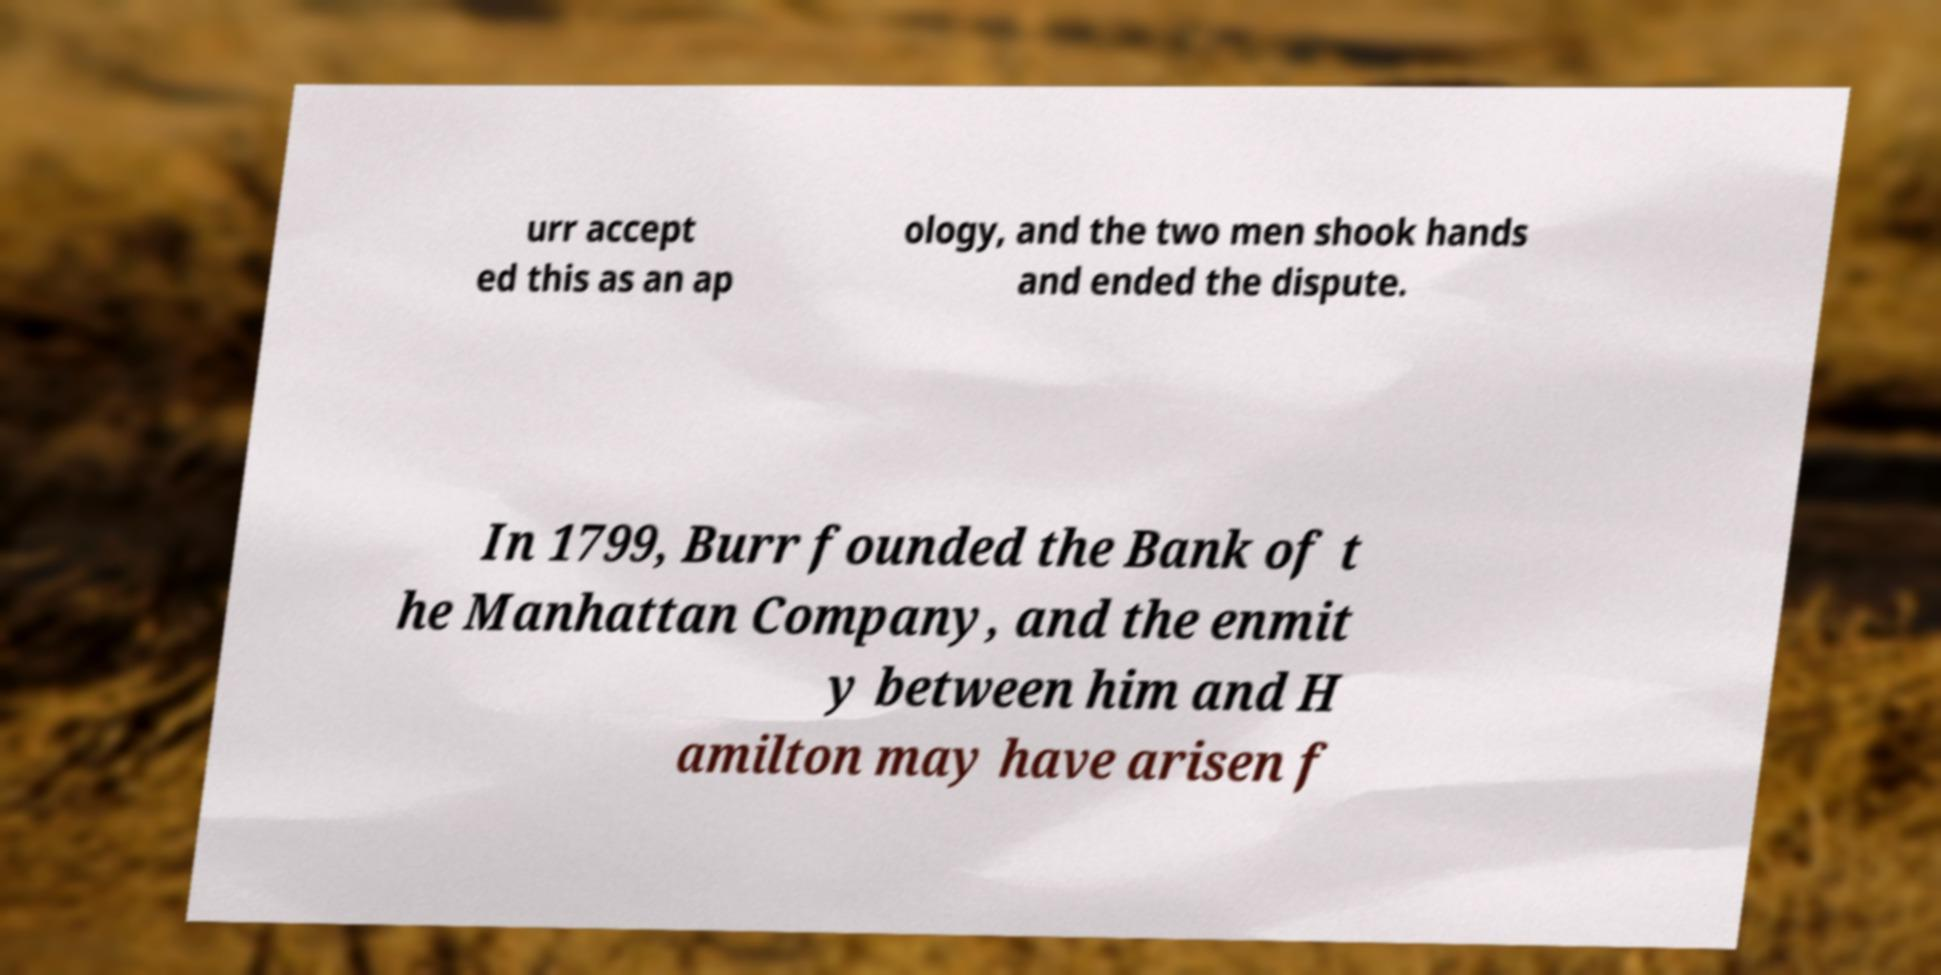I need the written content from this picture converted into text. Can you do that? urr accept ed this as an ap ology, and the two men shook hands and ended the dispute. In 1799, Burr founded the Bank of t he Manhattan Company, and the enmit y between him and H amilton may have arisen f 